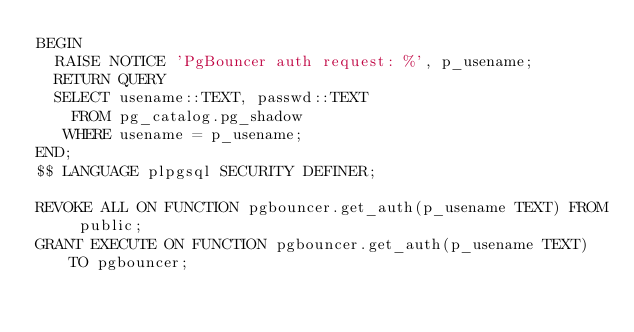Convert code to text. <code><loc_0><loc_0><loc_500><loc_500><_SQL_>BEGIN
  RAISE NOTICE 'PgBouncer auth request: %', p_usename;
  RETURN QUERY
  SELECT usename::TEXT, passwd::TEXT
    FROM pg_catalog.pg_shadow
   WHERE usename = p_usename;
END;
$$ LANGUAGE plpgsql SECURITY DEFINER;

REVOKE ALL ON FUNCTION pgbouncer.get_auth(p_usename TEXT) FROM public;
GRANT EXECUTE ON FUNCTION pgbouncer.get_auth(p_usename TEXT) TO pgbouncer;
</code> 